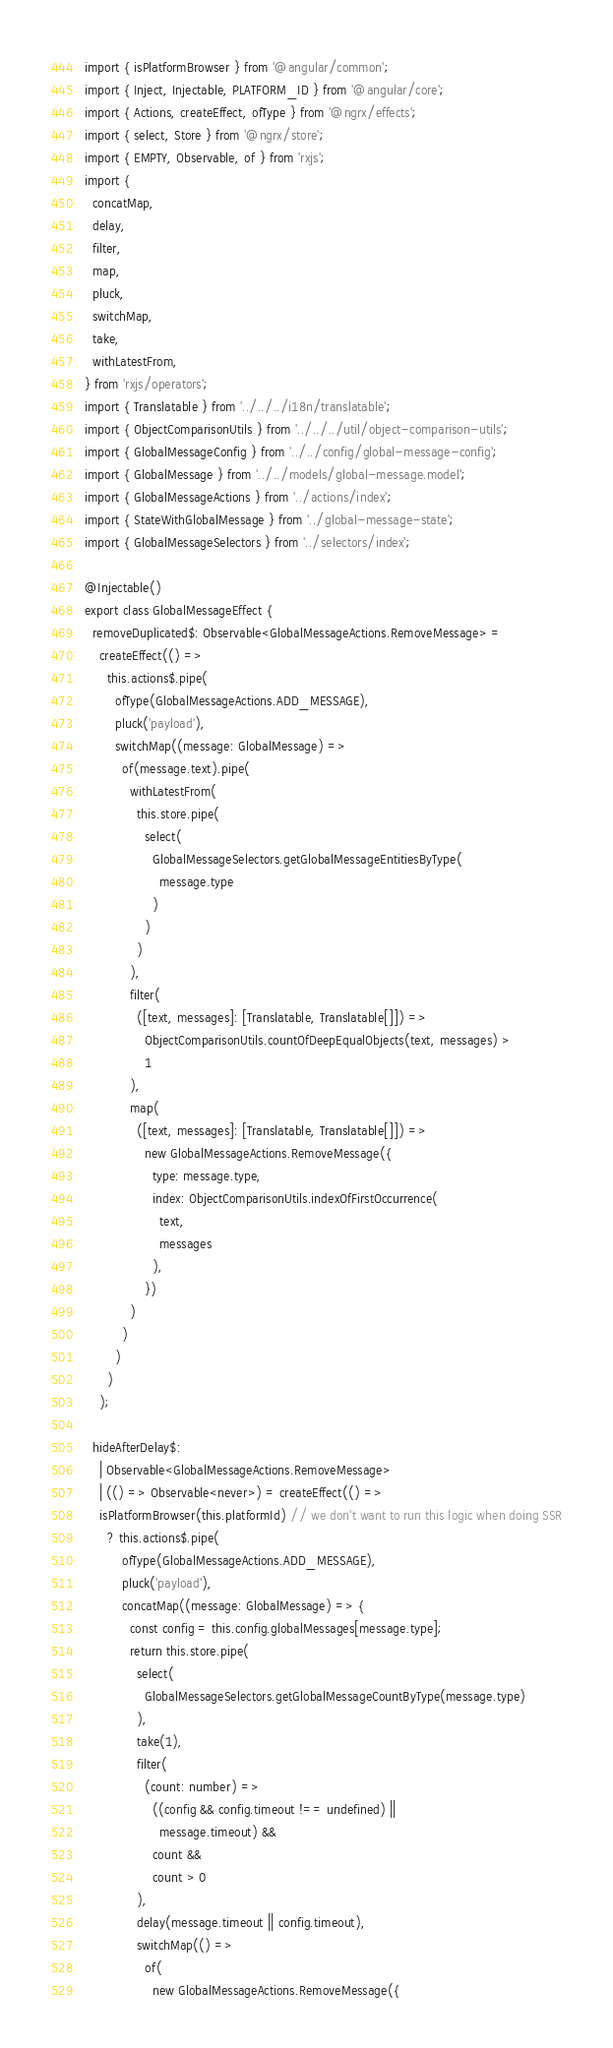Convert code to text. <code><loc_0><loc_0><loc_500><loc_500><_TypeScript_>import { isPlatformBrowser } from '@angular/common';
import { Inject, Injectable, PLATFORM_ID } from '@angular/core';
import { Actions, createEffect, ofType } from '@ngrx/effects';
import { select, Store } from '@ngrx/store';
import { EMPTY, Observable, of } from 'rxjs';
import {
  concatMap,
  delay,
  filter,
  map,
  pluck,
  switchMap,
  take,
  withLatestFrom,
} from 'rxjs/operators';
import { Translatable } from '../../../i18n/translatable';
import { ObjectComparisonUtils } from '../../../util/object-comparison-utils';
import { GlobalMessageConfig } from '../../config/global-message-config';
import { GlobalMessage } from '../../models/global-message.model';
import { GlobalMessageActions } from '../actions/index';
import { StateWithGlobalMessage } from '../global-message-state';
import { GlobalMessageSelectors } from '../selectors/index';

@Injectable()
export class GlobalMessageEffect {
  removeDuplicated$: Observable<GlobalMessageActions.RemoveMessage> =
    createEffect(() =>
      this.actions$.pipe(
        ofType(GlobalMessageActions.ADD_MESSAGE),
        pluck('payload'),
        switchMap((message: GlobalMessage) =>
          of(message.text).pipe(
            withLatestFrom(
              this.store.pipe(
                select(
                  GlobalMessageSelectors.getGlobalMessageEntitiesByType(
                    message.type
                  )
                )
              )
            ),
            filter(
              ([text, messages]: [Translatable, Translatable[]]) =>
                ObjectComparisonUtils.countOfDeepEqualObjects(text, messages) >
                1
            ),
            map(
              ([text, messages]: [Translatable, Translatable[]]) =>
                new GlobalMessageActions.RemoveMessage({
                  type: message.type,
                  index: ObjectComparisonUtils.indexOfFirstOccurrence(
                    text,
                    messages
                  ),
                })
            )
          )
        )
      )
    );

  hideAfterDelay$:
    | Observable<GlobalMessageActions.RemoveMessage>
    | (() => Observable<never>) = createEffect(() =>
    isPlatformBrowser(this.platformId) // we don't want to run this logic when doing SSR
      ? this.actions$.pipe(
          ofType(GlobalMessageActions.ADD_MESSAGE),
          pluck('payload'),
          concatMap((message: GlobalMessage) => {
            const config = this.config.globalMessages[message.type];
            return this.store.pipe(
              select(
                GlobalMessageSelectors.getGlobalMessageCountByType(message.type)
              ),
              take(1),
              filter(
                (count: number) =>
                  ((config && config.timeout !== undefined) ||
                    message.timeout) &&
                  count &&
                  count > 0
              ),
              delay(message.timeout || config.timeout),
              switchMap(() =>
                of(
                  new GlobalMessageActions.RemoveMessage({</code> 